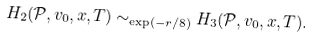Convert formula to latex. <formula><loc_0><loc_0><loc_500><loc_500>H _ { 2 } ( \mathcal { P } , v _ { 0 } , x , T ) \sim _ { \exp ( - r / 8 ) } H _ { 3 } ( \mathcal { P } , v _ { 0 } , x , T ) .</formula> 